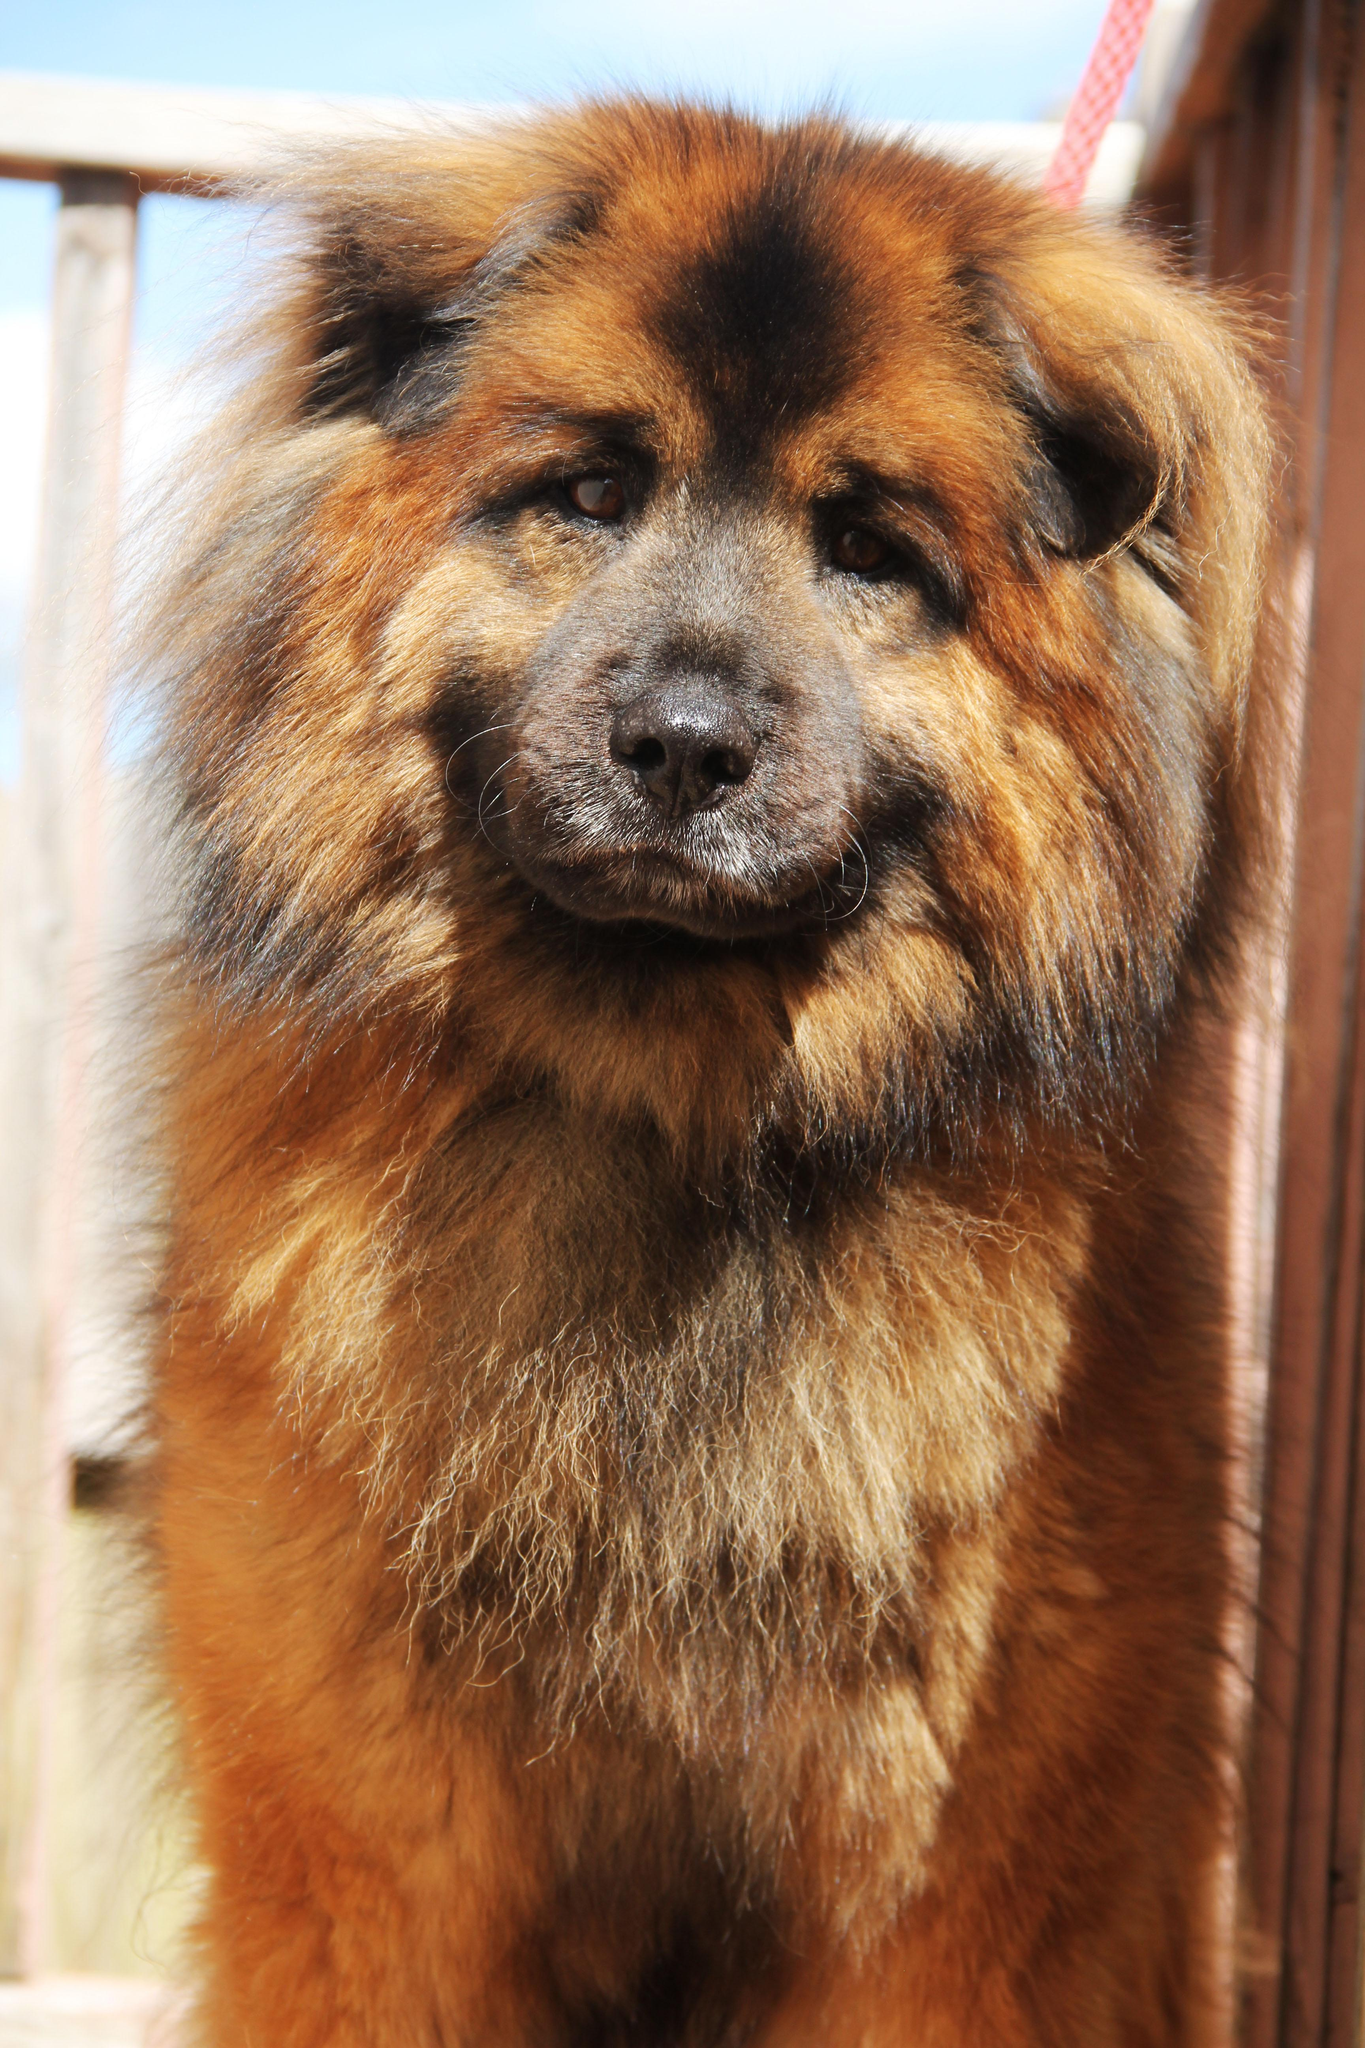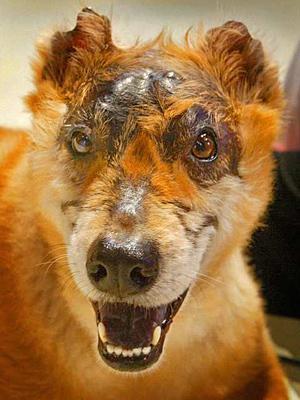The first image is the image on the left, the second image is the image on the right. Assess this claim about the two images: "One of the dogs is on a leash outdoors, in front of a leg clad in pants.". Correct or not? Answer yes or no. No. The first image is the image on the left, the second image is the image on the right. Examine the images to the left and right. Is the description "You can see one dog's feet in the grass." accurate? Answer yes or no. No. 